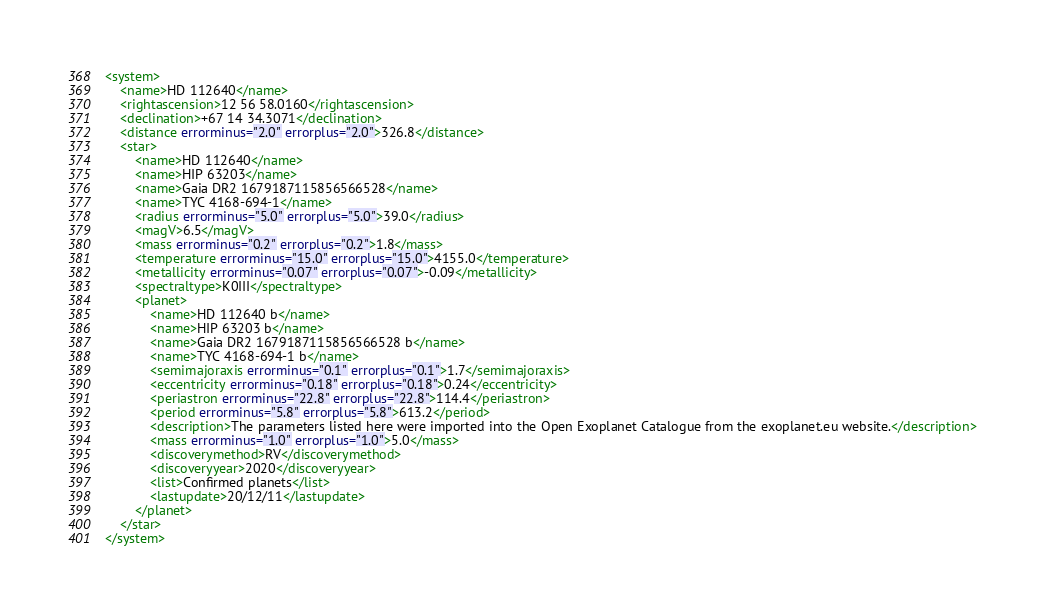<code> <loc_0><loc_0><loc_500><loc_500><_XML_><system>
	<name>HD 112640</name>
	<rightascension>12 56 58.0160</rightascension>
	<declination>+67 14 34.3071</declination>
	<distance errorminus="2.0" errorplus="2.0">326.8</distance>
	<star>
		<name>HD 112640</name>
		<name>HIP 63203</name>
		<name>Gaia DR2 1679187115856566528</name>
		<name>TYC 4168-694-1</name>
		<radius errorminus="5.0" errorplus="5.0">39.0</radius>
		<magV>6.5</magV>
		<mass errorminus="0.2" errorplus="0.2">1.8</mass>
		<temperature errorminus="15.0" errorplus="15.0">4155.0</temperature>
		<metallicity errorminus="0.07" errorplus="0.07">-0.09</metallicity>
		<spectraltype>K0III</spectraltype>
		<planet>
			<name>HD 112640 b</name>
			<name>HIP 63203 b</name>
			<name>Gaia DR2 1679187115856566528 b</name>
			<name>TYC 4168-694-1 b</name>
			<semimajoraxis errorminus="0.1" errorplus="0.1">1.7</semimajoraxis>
			<eccentricity errorminus="0.18" errorplus="0.18">0.24</eccentricity>
			<periastron errorminus="22.8" errorplus="22.8">114.4</periastron>
			<period errorminus="5.8" errorplus="5.8">613.2</period>
			<description>The parameters listed here were imported into the Open Exoplanet Catalogue from the exoplanet.eu website.</description>
			<mass errorminus="1.0" errorplus="1.0">5.0</mass>
			<discoverymethod>RV</discoverymethod>
			<discoveryyear>2020</discoveryyear>
			<list>Confirmed planets</list>
			<lastupdate>20/12/11</lastupdate>
		</planet>
	</star>
</system>
</code> 